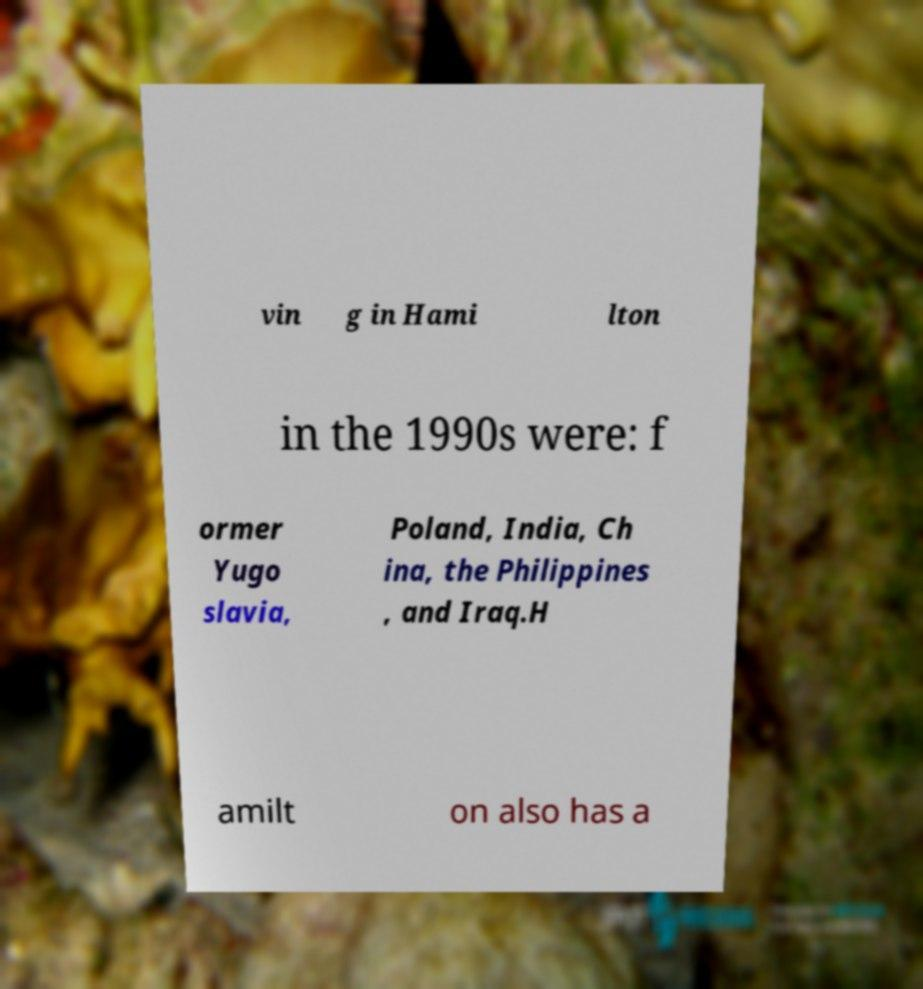Can you accurately transcribe the text from the provided image for me? vin g in Hami lton in the 1990s were: f ormer Yugo slavia, Poland, India, Ch ina, the Philippines , and Iraq.H amilt on also has a 